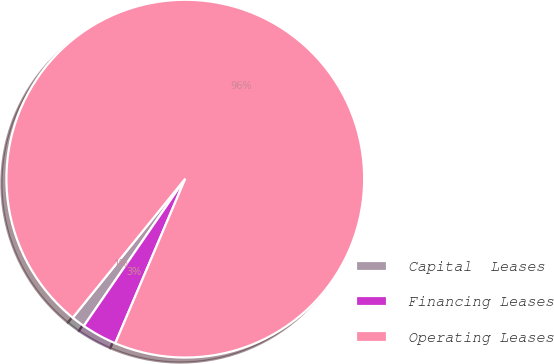<chart> <loc_0><loc_0><loc_500><loc_500><pie_chart><fcel>Capital  Leases<fcel>Financing Leases<fcel>Operating Leases<nl><fcel>1.23%<fcel>3.2%<fcel>95.57%<nl></chart> 